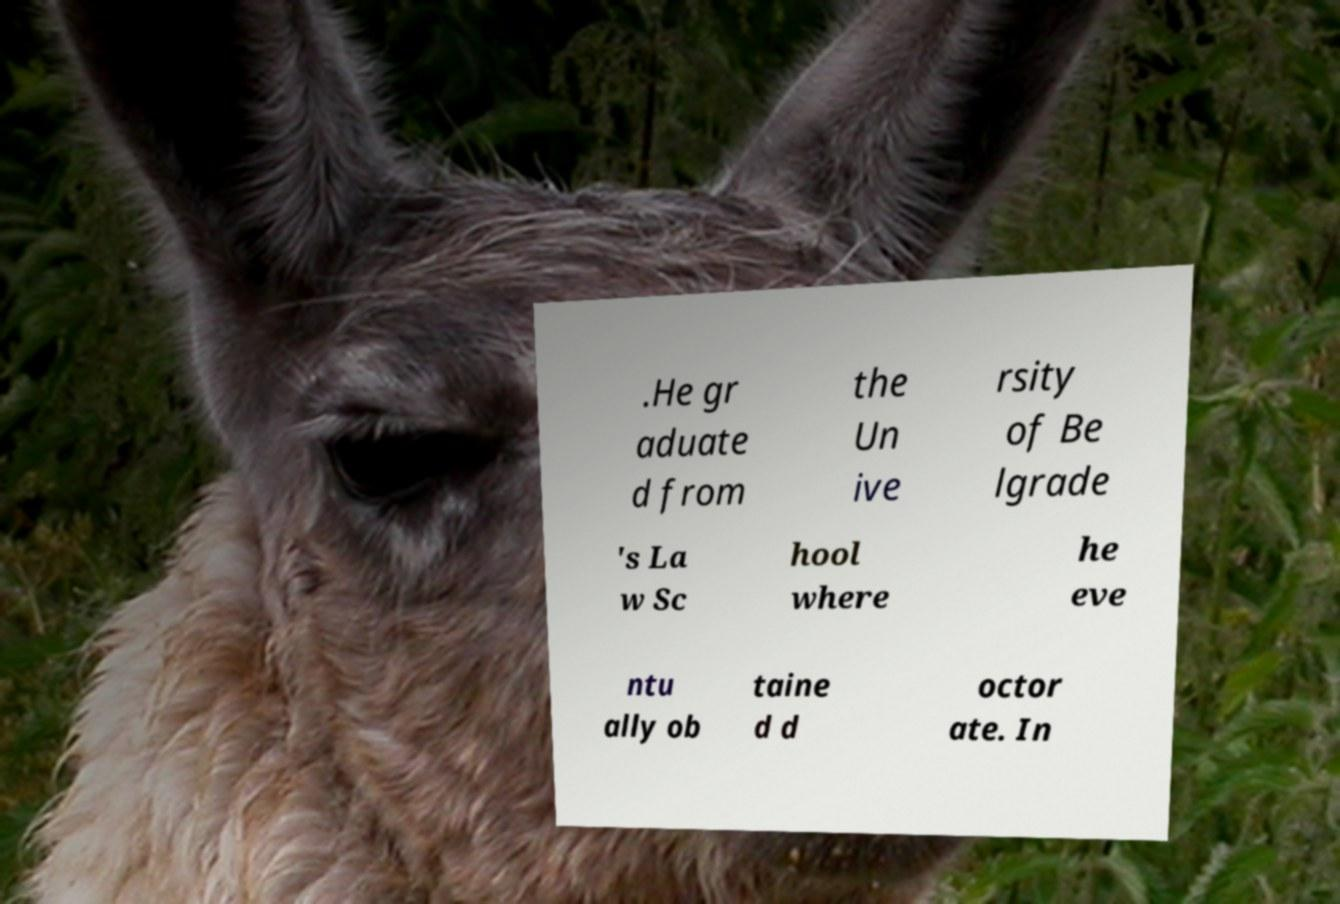Can you read and provide the text displayed in the image?This photo seems to have some interesting text. Can you extract and type it out for me? .He gr aduate d from the Un ive rsity of Be lgrade 's La w Sc hool where he eve ntu ally ob taine d d octor ate. In 